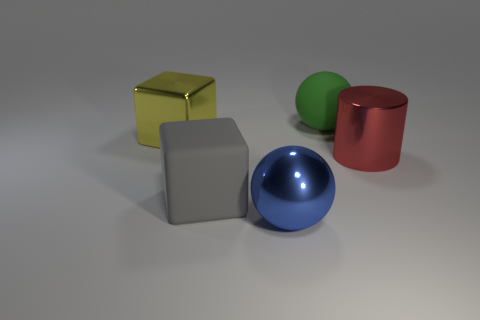Add 2 big purple rubber spheres. How many objects exist? 7 Subtract all gray cubes. How many cubes are left? 1 Subtract all purple cubes. Subtract all gray cylinders. How many cubes are left? 2 Add 1 red cylinders. How many red cylinders exist? 2 Subtract 0 red blocks. How many objects are left? 5 Subtract all cylinders. How many objects are left? 4 Subtract all small red matte cubes. Subtract all big objects. How many objects are left? 0 Add 1 green objects. How many green objects are left? 2 